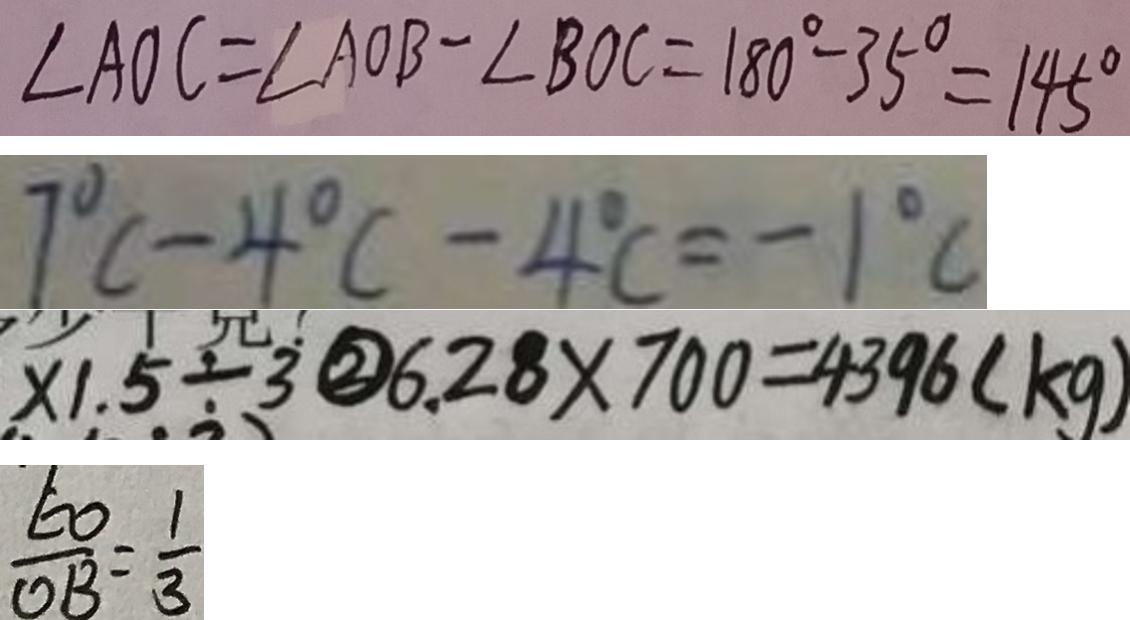Convert formula to latex. <formula><loc_0><loc_0><loc_500><loc_500>\angle A O C = \angle A O B - \angle B O C = 1 8 0 ^ { \circ } - 3 5 ^ { \circ } = 1 4 5 ^ { \circ } 
 7 ^ { \circ } C - 4 ^ { \circ } C - 4 ^ { \circ } C = - 1 ^ { \circ } C 
 x 1 . 5 \div 3 \textcircled { 2 } 6 . 2 8 \times 7 0 0 = 4 3 9 6 ( k g ) 
 \frac { E O } { O B } = \frac { 1 } { 3 }</formula> 